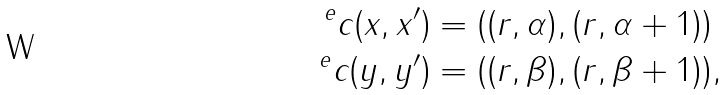<formula> <loc_0><loc_0><loc_500><loc_500>^ { e } c ( x , x ^ { \prime } ) & = ( ( r , \alpha ) , ( r , \alpha + 1 ) ) \\ ^ { e } c ( y , y ^ { \prime } ) & = ( ( r , \beta ) , ( r , \beta + 1 ) ) ,</formula> 